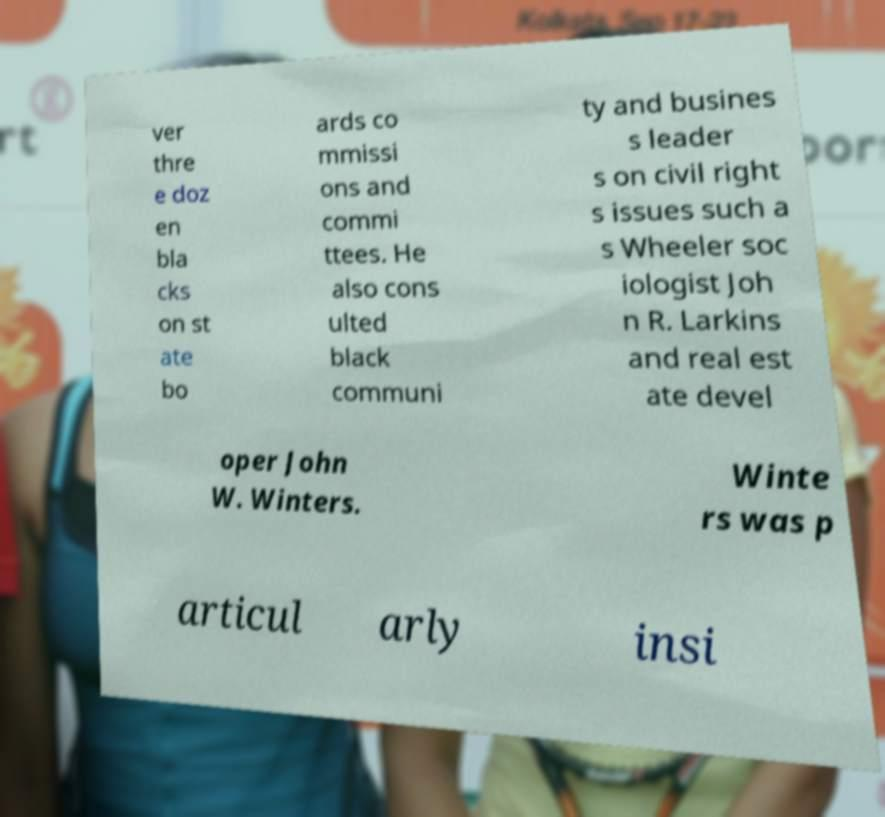Could you extract and type out the text from this image? ver thre e doz en bla cks on st ate bo ards co mmissi ons and commi ttees. He also cons ulted black communi ty and busines s leader s on civil right s issues such a s Wheeler soc iologist Joh n R. Larkins and real est ate devel oper John W. Winters. Winte rs was p articul arly insi 